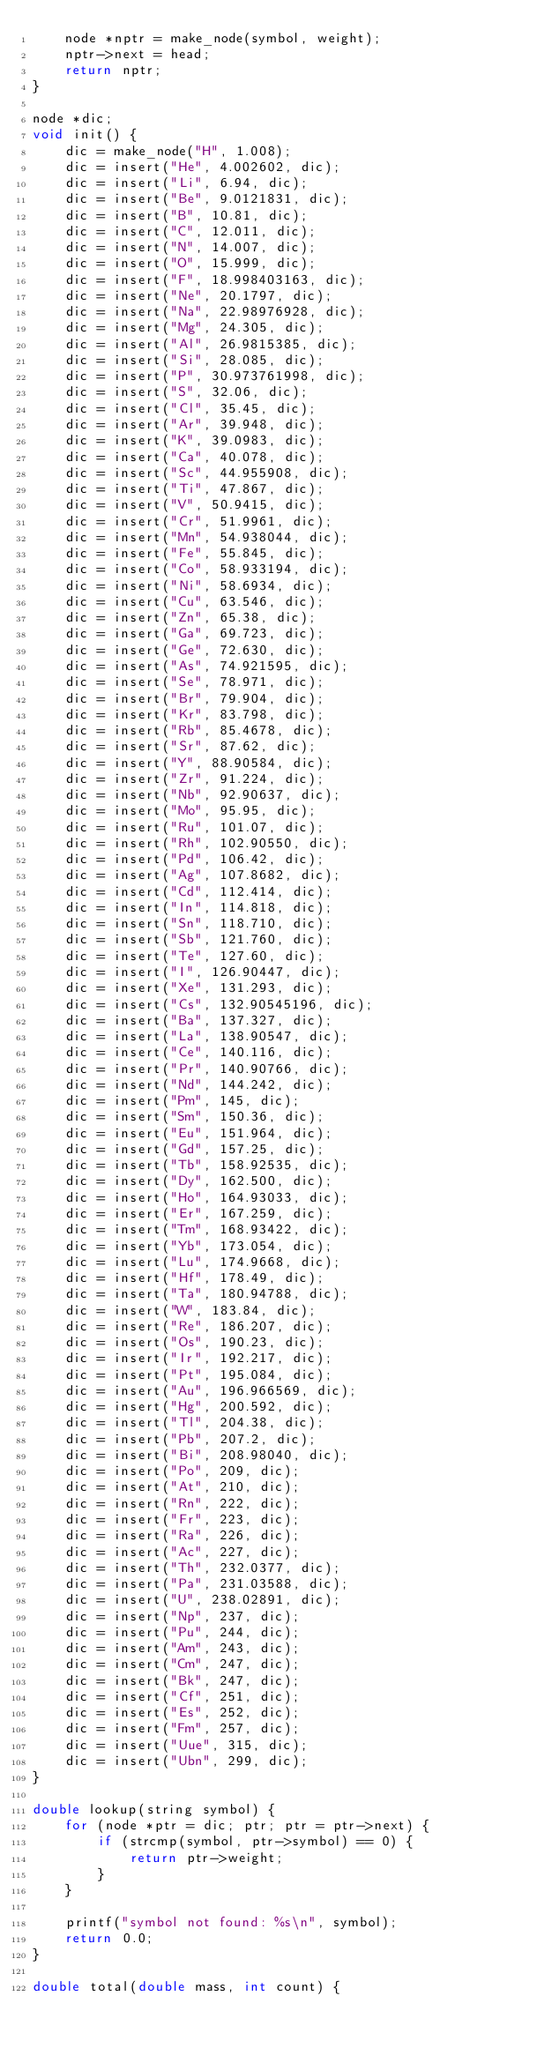<code> <loc_0><loc_0><loc_500><loc_500><_C_>    node *nptr = make_node(symbol, weight);
    nptr->next = head;
    return nptr;
}

node *dic;
void init() {
    dic = make_node("H", 1.008);
    dic = insert("He", 4.002602, dic);
    dic = insert("Li", 6.94, dic);
    dic = insert("Be", 9.0121831, dic);
    dic = insert("B", 10.81, dic);
    dic = insert("C", 12.011, dic);
    dic = insert("N", 14.007, dic);
    dic = insert("O", 15.999, dic);
    dic = insert("F", 18.998403163, dic);
    dic = insert("Ne", 20.1797, dic);
    dic = insert("Na", 22.98976928, dic);
    dic = insert("Mg", 24.305, dic);
    dic = insert("Al", 26.9815385, dic);
    dic = insert("Si", 28.085, dic);
    dic = insert("P", 30.973761998, dic);
    dic = insert("S", 32.06, dic);
    dic = insert("Cl", 35.45, dic);
    dic = insert("Ar", 39.948, dic);
    dic = insert("K", 39.0983, dic);
    dic = insert("Ca", 40.078, dic);
    dic = insert("Sc", 44.955908, dic);
    dic = insert("Ti", 47.867, dic);
    dic = insert("V", 50.9415, dic);
    dic = insert("Cr", 51.9961, dic);
    dic = insert("Mn", 54.938044, dic);
    dic = insert("Fe", 55.845, dic);
    dic = insert("Co", 58.933194, dic);
    dic = insert("Ni", 58.6934, dic);
    dic = insert("Cu", 63.546, dic);
    dic = insert("Zn", 65.38, dic);
    dic = insert("Ga", 69.723, dic);
    dic = insert("Ge", 72.630, dic);
    dic = insert("As", 74.921595, dic);
    dic = insert("Se", 78.971, dic);
    dic = insert("Br", 79.904, dic);
    dic = insert("Kr", 83.798, dic);
    dic = insert("Rb", 85.4678, dic);
    dic = insert("Sr", 87.62, dic);
    dic = insert("Y", 88.90584, dic);
    dic = insert("Zr", 91.224, dic);
    dic = insert("Nb", 92.90637, dic);
    dic = insert("Mo", 95.95, dic);
    dic = insert("Ru", 101.07, dic);
    dic = insert("Rh", 102.90550, dic);
    dic = insert("Pd", 106.42, dic);
    dic = insert("Ag", 107.8682, dic);
    dic = insert("Cd", 112.414, dic);
    dic = insert("In", 114.818, dic);
    dic = insert("Sn", 118.710, dic);
    dic = insert("Sb", 121.760, dic);
    dic = insert("Te", 127.60, dic);
    dic = insert("I", 126.90447, dic);
    dic = insert("Xe", 131.293, dic);
    dic = insert("Cs", 132.90545196, dic);
    dic = insert("Ba", 137.327, dic);
    dic = insert("La", 138.90547, dic);
    dic = insert("Ce", 140.116, dic);
    dic = insert("Pr", 140.90766, dic);
    dic = insert("Nd", 144.242, dic);
    dic = insert("Pm", 145, dic);
    dic = insert("Sm", 150.36, dic);
    dic = insert("Eu", 151.964, dic);
    dic = insert("Gd", 157.25, dic);
    dic = insert("Tb", 158.92535, dic);
    dic = insert("Dy", 162.500, dic);
    dic = insert("Ho", 164.93033, dic);
    dic = insert("Er", 167.259, dic);
    dic = insert("Tm", 168.93422, dic);
    dic = insert("Yb", 173.054, dic);
    dic = insert("Lu", 174.9668, dic);
    dic = insert("Hf", 178.49, dic);
    dic = insert("Ta", 180.94788, dic);
    dic = insert("W", 183.84, dic);
    dic = insert("Re", 186.207, dic);
    dic = insert("Os", 190.23, dic);
    dic = insert("Ir", 192.217, dic);
    dic = insert("Pt", 195.084, dic);
    dic = insert("Au", 196.966569, dic);
    dic = insert("Hg", 200.592, dic);
    dic = insert("Tl", 204.38, dic);
    dic = insert("Pb", 207.2, dic);
    dic = insert("Bi", 208.98040, dic);
    dic = insert("Po", 209, dic);
    dic = insert("At", 210, dic);
    dic = insert("Rn", 222, dic);
    dic = insert("Fr", 223, dic);
    dic = insert("Ra", 226, dic);
    dic = insert("Ac", 227, dic);
    dic = insert("Th", 232.0377, dic);
    dic = insert("Pa", 231.03588, dic);
    dic = insert("U", 238.02891, dic);
    dic = insert("Np", 237, dic);
    dic = insert("Pu", 244, dic);
    dic = insert("Am", 243, dic);
    dic = insert("Cm", 247, dic);
    dic = insert("Bk", 247, dic);
    dic = insert("Cf", 251, dic);
    dic = insert("Es", 252, dic);
    dic = insert("Fm", 257, dic);
    dic = insert("Uue", 315, dic);
    dic = insert("Ubn", 299, dic);
}

double lookup(string symbol) {
    for (node *ptr = dic; ptr; ptr = ptr->next) {
        if (strcmp(symbol, ptr->symbol) == 0) {
            return ptr->weight;
        }
    }

    printf("symbol not found: %s\n", symbol);
    return 0.0;
}

double total(double mass, int count) {</code> 